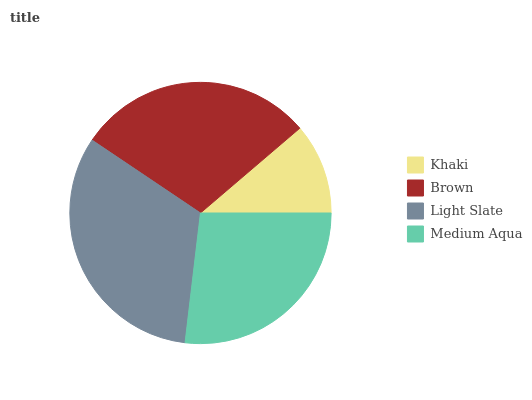Is Khaki the minimum?
Answer yes or no. Yes. Is Light Slate the maximum?
Answer yes or no. Yes. Is Brown the minimum?
Answer yes or no. No. Is Brown the maximum?
Answer yes or no. No. Is Brown greater than Khaki?
Answer yes or no. Yes. Is Khaki less than Brown?
Answer yes or no. Yes. Is Khaki greater than Brown?
Answer yes or no. No. Is Brown less than Khaki?
Answer yes or no. No. Is Brown the high median?
Answer yes or no. Yes. Is Medium Aqua the low median?
Answer yes or no. Yes. Is Medium Aqua the high median?
Answer yes or no. No. Is Khaki the low median?
Answer yes or no. No. 